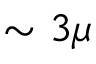Convert formula to latex. <formula><loc_0><loc_0><loc_500><loc_500>\sim 3 \mu</formula> 